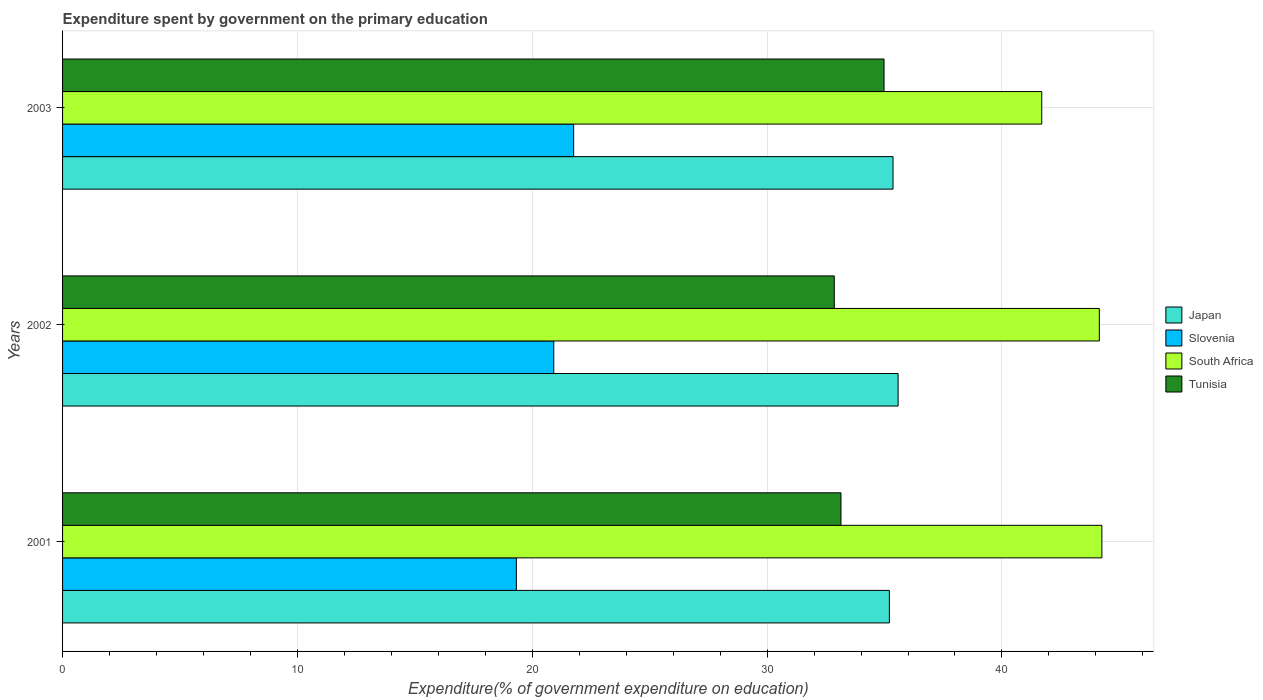Are the number of bars on each tick of the Y-axis equal?
Ensure brevity in your answer.  Yes. How many bars are there on the 3rd tick from the top?
Your answer should be very brief. 4. How many bars are there on the 2nd tick from the bottom?
Your answer should be very brief. 4. What is the label of the 3rd group of bars from the top?
Your answer should be compact. 2001. In how many cases, is the number of bars for a given year not equal to the number of legend labels?
Your answer should be compact. 0. What is the expenditure spent by government on the primary education in Slovenia in 2002?
Make the answer very short. 20.92. Across all years, what is the maximum expenditure spent by government on the primary education in Japan?
Offer a very short reply. 35.58. Across all years, what is the minimum expenditure spent by government on the primary education in Tunisia?
Offer a terse response. 32.86. What is the total expenditure spent by government on the primary education in Tunisia in the graph?
Keep it short and to the point. 100.99. What is the difference between the expenditure spent by government on the primary education in Japan in 2001 and that in 2002?
Offer a very short reply. -0.37. What is the difference between the expenditure spent by government on the primary education in Japan in 2001 and the expenditure spent by government on the primary education in South Africa in 2003?
Your answer should be very brief. -6.49. What is the average expenditure spent by government on the primary education in Tunisia per year?
Your answer should be very brief. 33.66. In the year 2003, what is the difference between the expenditure spent by government on the primary education in Japan and expenditure spent by government on the primary education in Slovenia?
Keep it short and to the point. 13.6. In how many years, is the expenditure spent by government on the primary education in Japan greater than 24 %?
Keep it short and to the point. 3. What is the ratio of the expenditure spent by government on the primary education in Slovenia in 2001 to that in 2002?
Keep it short and to the point. 0.92. Is the expenditure spent by government on the primary education in Japan in 2001 less than that in 2002?
Your answer should be very brief. Yes. What is the difference between the highest and the second highest expenditure spent by government on the primary education in Japan?
Your answer should be very brief. 0.22. What is the difference between the highest and the lowest expenditure spent by government on the primary education in South Africa?
Provide a succinct answer. 2.56. Is the sum of the expenditure spent by government on the primary education in Tunisia in 2001 and 2003 greater than the maximum expenditure spent by government on the primary education in South Africa across all years?
Ensure brevity in your answer.  Yes. Is it the case that in every year, the sum of the expenditure spent by government on the primary education in Slovenia and expenditure spent by government on the primary education in South Africa is greater than the sum of expenditure spent by government on the primary education in Tunisia and expenditure spent by government on the primary education in Japan?
Your answer should be very brief. Yes. What does the 2nd bar from the top in 2001 represents?
Your answer should be very brief. South Africa. What does the 1st bar from the bottom in 2001 represents?
Make the answer very short. Japan. Does the graph contain grids?
Your response must be concise. Yes. Where does the legend appear in the graph?
Provide a succinct answer. Center right. How are the legend labels stacked?
Provide a succinct answer. Vertical. What is the title of the graph?
Make the answer very short. Expenditure spent by government on the primary education. Does "Lao PDR" appear as one of the legend labels in the graph?
Keep it short and to the point. No. What is the label or title of the X-axis?
Offer a very short reply. Expenditure(% of government expenditure on education). What is the label or title of the Y-axis?
Your answer should be very brief. Years. What is the Expenditure(% of government expenditure on education) of Japan in 2001?
Offer a very short reply. 35.21. What is the Expenditure(% of government expenditure on education) in Slovenia in 2001?
Provide a short and direct response. 19.32. What is the Expenditure(% of government expenditure on education) in South Africa in 2001?
Offer a very short reply. 44.26. What is the Expenditure(% of government expenditure on education) in Tunisia in 2001?
Offer a terse response. 33.15. What is the Expenditure(% of government expenditure on education) of Japan in 2002?
Ensure brevity in your answer.  35.58. What is the Expenditure(% of government expenditure on education) in Slovenia in 2002?
Your answer should be compact. 20.92. What is the Expenditure(% of government expenditure on education) in South Africa in 2002?
Your response must be concise. 44.15. What is the Expenditure(% of government expenditure on education) in Tunisia in 2002?
Offer a terse response. 32.86. What is the Expenditure(% of government expenditure on education) in Japan in 2003?
Your answer should be compact. 35.36. What is the Expenditure(% of government expenditure on education) in Slovenia in 2003?
Provide a short and direct response. 21.76. What is the Expenditure(% of government expenditure on education) of South Africa in 2003?
Offer a terse response. 41.7. What is the Expenditure(% of government expenditure on education) in Tunisia in 2003?
Your response must be concise. 34.98. Across all years, what is the maximum Expenditure(% of government expenditure on education) of Japan?
Ensure brevity in your answer.  35.58. Across all years, what is the maximum Expenditure(% of government expenditure on education) of Slovenia?
Provide a succinct answer. 21.76. Across all years, what is the maximum Expenditure(% of government expenditure on education) of South Africa?
Give a very brief answer. 44.26. Across all years, what is the maximum Expenditure(% of government expenditure on education) of Tunisia?
Provide a short and direct response. 34.98. Across all years, what is the minimum Expenditure(% of government expenditure on education) of Japan?
Keep it short and to the point. 35.21. Across all years, what is the minimum Expenditure(% of government expenditure on education) of Slovenia?
Your answer should be very brief. 19.32. Across all years, what is the minimum Expenditure(% of government expenditure on education) of South Africa?
Provide a succinct answer. 41.7. Across all years, what is the minimum Expenditure(% of government expenditure on education) of Tunisia?
Offer a terse response. 32.86. What is the total Expenditure(% of government expenditure on education) in Japan in the graph?
Make the answer very short. 106.15. What is the total Expenditure(% of government expenditure on education) in Slovenia in the graph?
Ensure brevity in your answer.  62. What is the total Expenditure(% of government expenditure on education) of South Africa in the graph?
Keep it short and to the point. 130.1. What is the total Expenditure(% of government expenditure on education) of Tunisia in the graph?
Your answer should be very brief. 100.99. What is the difference between the Expenditure(% of government expenditure on education) of Japan in 2001 and that in 2002?
Offer a very short reply. -0.37. What is the difference between the Expenditure(% of government expenditure on education) in Slovenia in 2001 and that in 2002?
Keep it short and to the point. -1.59. What is the difference between the Expenditure(% of government expenditure on education) in South Africa in 2001 and that in 2002?
Offer a very short reply. 0.11. What is the difference between the Expenditure(% of government expenditure on education) of Tunisia in 2001 and that in 2002?
Provide a short and direct response. 0.29. What is the difference between the Expenditure(% of government expenditure on education) of Japan in 2001 and that in 2003?
Ensure brevity in your answer.  -0.16. What is the difference between the Expenditure(% of government expenditure on education) in Slovenia in 2001 and that in 2003?
Your answer should be compact. -2.44. What is the difference between the Expenditure(% of government expenditure on education) of South Africa in 2001 and that in 2003?
Keep it short and to the point. 2.56. What is the difference between the Expenditure(% of government expenditure on education) of Tunisia in 2001 and that in 2003?
Ensure brevity in your answer.  -1.83. What is the difference between the Expenditure(% of government expenditure on education) of Japan in 2002 and that in 2003?
Provide a short and direct response. 0.22. What is the difference between the Expenditure(% of government expenditure on education) in Slovenia in 2002 and that in 2003?
Your answer should be compact. -0.85. What is the difference between the Expenditure(% of government expenditure on education) of South Africa in 2002 and that in 2003?
Keep it short and to the point. 2.45. What is the difference between the Expenditure(% of government expenditure on education) of Tunisia in 2002 and that in 2003?
Provide a short and direct response. -2.12. What is the difference between the Expenditure(% of government expenditure on education) of Japan in 2001 and the Expenditure(% of government expenditure on education) of Slovenia in 2002?
Keep it short and to the point. 14.29. What is the difference between the Expenditure(% of government expenditure on education) in Japan in 2001 and the Expenditure(% of government expenditure on education) in South Africa in 2002?
Provide a succinct answer. -8.94. What is the difference between the Expenditure(% of government expenditure on education) in Japan in 2001 and the Expenditure(% of government expenditure on education) in Tunisia in 2002?
Your answer should be compact. 2.35. What is the difference between the Expenditure(% of government expenditure on education) of Slovenia in 2001 and the Expenditure(% of government expenditure on education) of South Africa in 2002?
Your response must be concise. -24.82. What is the difference between the Expenditure(% of government expenditure on education) of Slovenia in 2001 and the Expenditure(% of government expenditure on education) of Tunisia in 2002?
Keep it short and to the point. -13.54. What is the difference between the Expenditure(% of government expenditure on education) of South Africa in 2001 and the Expenditure(% of government expenditure on education) of Tunisia in 2002?
Your response must be concise. 11.4. What is the difference between the Expenditure(% of government expenditure on education) of Japan in 2001 and the Expenditure(% of government expenditure on education) of Slovenia in 2003?
Give a very brief answer. 13.44. What is the difference between the Expenditure(% of government expenditure on education) of Japan in 2001 and the Expenditure(% of government expenditure on education) of South Africa in 2003?
Offer a terse response. -6.49. What is the difference between the Expenditure(% of government expenditure on education) of Japan in 2001 and the Expenditure(% of government expenditure on education) of Tunisia in 2003?
Your answer should be compact. 0.23. What is the difference between the Expenditure(% of government expenditure on education) in Slovenia in 2001 and the Expenditure(% of government expenditure on education) in South Africa in 2003?
Offer a terse response. -22.37. What is the difference between the Expenditure(% of government expenditure on education) of Slovenia in 2001 and the Expenditure(% of government expenditure on education) of Tunisia in 2003?
Provide a short and direct response. -15.66. What is the difference between the Expenditure(% of government expenditure on education) in South Africa in 2001 and the Expenditure(% of government expenditure on education) in Tunisia in 2003?
Offer a terse response. 9.28. What is the difference between the Expenditure(% of government expenditure on education) of Japan in 2002 and the Expenditure(% of government expenditure on education) of Slovenia in 2003?
Make the answer very short. 13.82. What is the difference between the Expenditure(% of government expenditure on education) of Japan in 2002 and the Expenditure(% of government expenditure on education) of South Africa in 2003?
Offer a very short reply. -6.12. What is the difference between the Expenditure(% of government expenditure on education) in Japan in 2002 and the Expenditure(% of government expenditure on education) in Tunisia in 2003?
Give a very brief answer. 0.6. What is the difference between the Expenditure(% of government expenditure on education) in Slovenia in 2002 and the Expenditure(% of government expenditure on education) in South Africa in 2003?
Keep it short and to the point. -20.78. What is the difference between the Expenditure(% of government expenditure on education) of Slovenia in 2002 and the Expenditure(% of government expenditure on education) of Tunisia in 2003?
Provide a short and direct response. -14.06. What is the difference between the Expenditure(% of government expenditure on education) of South Africa in 2002 and the Expenditure(% of government expenditure on education) of Tunisia in 2003?
Your response must be concise. 9.17. What is the average Expenditure(% of government expenditure on education) of Japan per year?
Your answer should be very brief. 35.38. What is the average Expenditure(% of government expenditure on education) in Slovenia per year?
Your answer should be compact. 20.67. What is the average Expenditure(% of government expenditure on education) in South Africa per year?
Give a very brief answer. 43.37. What is the average Expenditure(% of government expenditure on education) of Tunisia per year?
Your answer should be very brief. 33.66. In the year 2001, what is the difference between the Expenditure(% of government expenditure on education) of Japan and Expenditure(% of government expenditure on education) of Slovenia?
Offer a very short reply. 15.88. In the year 2001, what is the difference between the Expenditure(% of government expenditure on education) in Japan and Expenditure(% of government expenditure on education) in South Africa?
Provide a short and direct response. -9.05. In the year 2001, what is the difference between the Expenditure(% of government expenditure on education) of Japan and Expenditure(% of government expenditure on education) of Tunisia?
Give a very brief answer. 2.06. In the year 2001, what is the difference between the Expenditure(% of government expenditure on education) of Slovenia and Expenditure(% of government expenditure on education) of South Africa?
Keep it short and to the point. -24.93. In the year 2001, what is the difference between the Expenditure(% of government expenditure on education) of Slovenia and Expenditure(% of government expenditure on education) of Tunisia?
Provide a succinct answer. -13.82. In the year 2001, what is the difference between the Expenditure(% of government expenditure on education) in South Africa and Expenditure(% of government expenditure on education) in Tunisia?
Your answer should be compact. 11.11. In the year 2002, what is the difference between the Expenditure(% of government expenditure on education) in Japan and Expenditure(% of government expenditure on education) in Slovenia?
Your answer should be very brief. 14.66. In the year 2002, what is the difference between the Expenditure(% of government expenditure on education) in Japan and Expenditure(% of government expenditure on education) in South Africa?
Offer a very short reply. -8.57. In the year 2002, what is the difference between the Expenditure(% of government expenditure on education) in Japan and Expenditure(% of government expenditure on education) in Tunisia?
Offer a terse response. 2.72. In the year 2002, what is the difference between the Expenditure(% of government expenditure on education) in Slovenia and Expenditure(% of government expenditure on education) in South Africa?
Offer a very short reply. -23.23. In the year 2002, what is the difference between the Expenditure(% of government expenditure on education) in Slovenia and Expenditure(% of government expenditure on education) in Tunisia?
Make the answer very short. -11.94. In the year 2002, what is the difference between the Expenditure(% of government expenditure on education) of South Africa and Expenditure(% of government expenditure on education) of Tunisia?
Keep it short and to the point. 11.29. In the year 2003, what is the difference between the Expenditure(% of government expenditure on education) of Japan and Expenditure(% of government expenditure on education) of Slovenia?
Your answer should be very brief. 13.6. In the year 2003, what is the difference between the Expenditure(% of government expenditure on education) of Japan and Expenditure(% of government expenditure on education) of South Africa?
Provide a short and direct response. -6.33. In the year 2003, what is the difference between the Expenditure(% of government expenditure on education) in Japan and Expenditure(% of government expenditure on education) in Tunisia?
Your answer should be very brief. 0.38. In the year 2003, what is the difference between the Expenditure(% of government expenditure on education) of Slovenia and Expenditure(% of government expenditure on education) of South Africa?
Give a very brief answer. -19.93. In the year 2003, what is the difference between the Expenditure(% of government expenditure on education) of Slovenia and Expenditure(% of government expenditure on education) of Tunisia?
Offer a terse response. -13.22. In the year 2003, what is the difference between the Expenditure(% of government expenditure on education) in South Africa and Expenditure(% of government expenditure on education) in Tunisia?
Ensure brevity in your answer.  6.72. What is the ratio of the Expenditure(% of government expenditure on education) in Japan in 2001 to that in 2002?
Provide a succinct answer. 0.99. What is the ratio of the Expenditure(% of government expenditure on education) of Slovenia in 2001 to that in 2002?
Keep it short and to the point. 0.92. What is the ratio of the Expenditure(% of government expenditure on education) of Tunisia in 2001 to that in 2002?
Make the answer very short. 1.01. What is the ratio of the Expenditure(% of government expenditure on education) in Japan in 2001 to that in 2003?
Offer a very short reply. 1. What is the ratio of the Expenditure(% of government expenditure on education) in Slovenia in 2001 to that in 2003?
Ensure brevity in your answer.  0.89. What is the ratio of the Expenditure(% of government expenditure on education) in South Africa in 2001 to that in 2003?
Keep it short and to the point. 1.06. What is the ratio of the Expenditure(% of government expenditure on education) of Tunisia in 2001 to that in 2003?
Offer a terse response. 0.95. What is the ratio of the Expenditure(% of government expenditure on education) in Japan in 2002 to that in 2003?
Provide a succinct answer. 1.01. What is the ratio of the Expenditure(% of government expenditure on education) in Slovenia in 2002 to that in 2003?
Provide a short and direct response. 0.96. What is the ratio of the Expenditure(% of government expenditure on education) in South Africa in 2002 to that in 2003?
Provide a short and direct response. 1.06. What is the ratio of the Expenditure(% of government expenditure on education) in Tunisia in 2002 to that in 2003?
Keep it short and to the point. 0.94. What is the difference between the highest and the second highest Expenditure(% of government expenditure on education) of Japan?
Your answer should be compact. 0.22. What is the difference between the highest and the second highest Expenditure(% of government expenditure on education) in Slovenia?
Offer a very short reply. 0.85. What is the difference between the highest and the second highest Expenditure(% of government expenditure on education) in South Africa?
Keep it short and to the point. 0.11. What is the difference between the highest and the second highest Expenditure(% of government expenditure on education) in Tunisia?
Give a very brief answer. 1.83. What is the difference between the highest and the lowest Expenditure(% of government expenditure on education) of Japan?
Your answer should be compact. 0.37. What is the difference between the highest and the lowest Expenditure(% of government expenditure on education) of Slovenia?
Your answer should be compact. 2.44. What is the difference between the highest and the lowest Expenditure(% of government expenditure on education) in South Africa?
Your answer should be compact. 2.56. What is the difference between the highest and the lowest Expenditure(% of government expenditure on education) in Tunisia?
Make the answer very short. 2.12. 